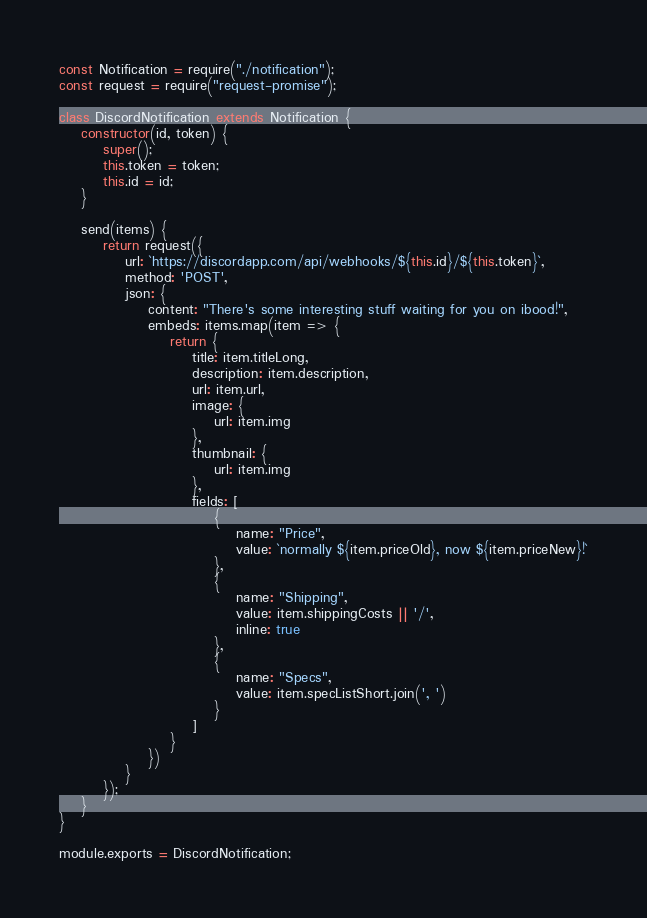Convert code to text. <code><loc_0><loc_0><loc_500><loc_500><_JavaScript_>const Notification = require("./notification");
const request = require("request-promise");

class DiscordNotification extends Notification {
    constructor(id, token) {
        super();
        this.token = token;
        this.id = id;
    }

    send(items) {
        return request({
            url: `https://discordapp.com/api/webhooks/${this.id}/${this.token}`,
            method: 'POST',
            json: {
                content: "There's some interesting stuff waiting for you on ibood!",
                embeds: items.map(item => {
                    return {
                        title: item.titleLong,
                        description: item.description,
                        url: item.url,
                        image: {
                            url: item.img
                        },
                        thumbnail: {
                            url: item.img
                        },
                        fields: [
                            {
                                name: "Price",
                                value: `normally ${item.priceOld}, now ${item.priceNew}!`
                            },
                            {
                                name: "Shipping",
                                value: item.shippingCosts || '/',
                                inline: true
                            },
                            {
                                name: "Specs",
                                value: item.specListShort.join(', ')
                            }
                        ]
                    }
                })
            }
        });
    }
}

module.exports = DiscordNotification;
</code> 